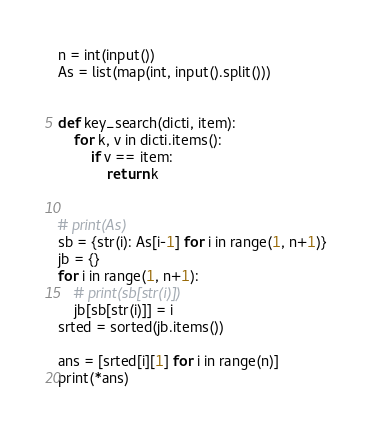<code> <loc_0><loc_0><loc_500><loc_500><_Python_>n = int(input())
As = list(map(int, input().split()))


def key_search(dicti, item):
    for k, v in dicti.items():
        if v == item:
            return k


# print(As)
sb = {str(i): As[i-1] for i in range(1, n+1)}
jb = {}
for i in range(1, n+1):
    # print(sb[str(i)])
    jb[sb[str(i)]] = i
srted = sorted(jb.items())

ans = [srted[i][1] for i in range(n)]
print(*ans)


</code> 